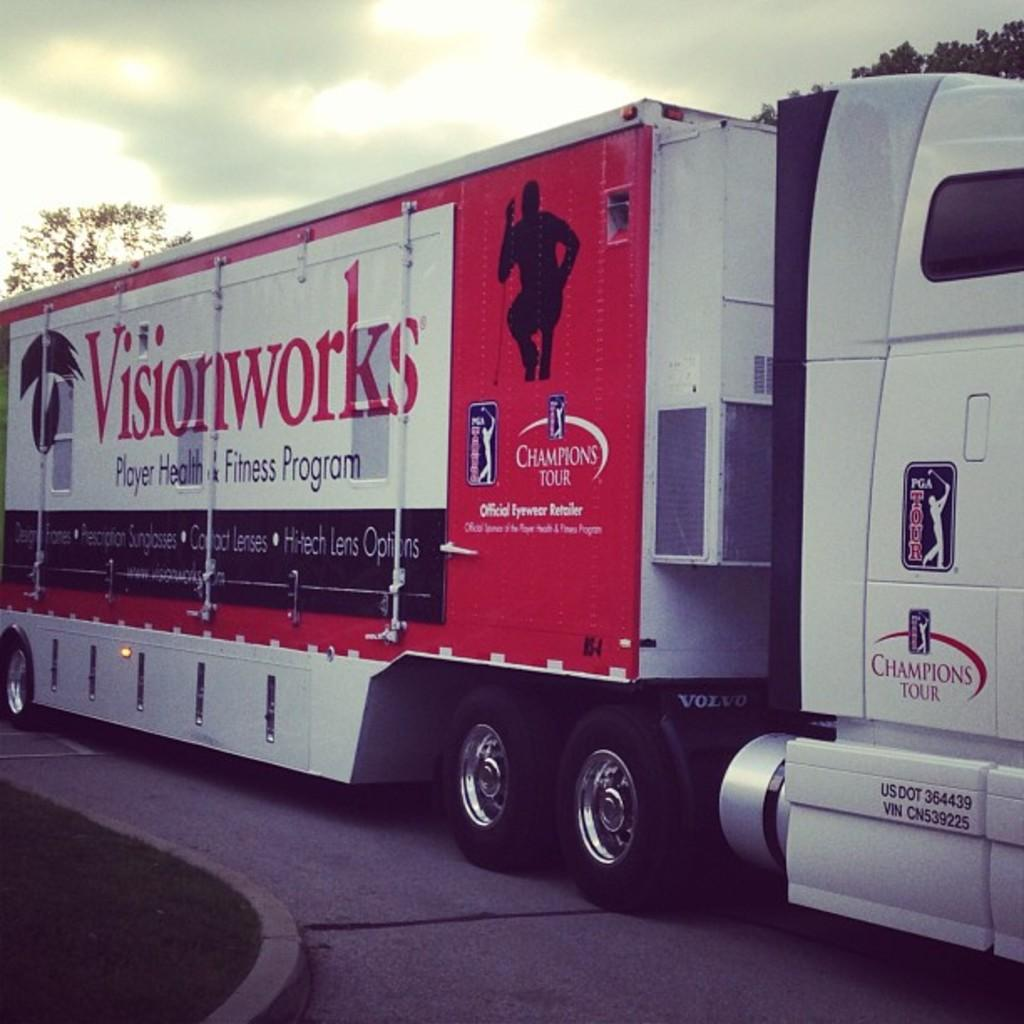What is the main subject of the image? There is a vehicle in the image. What colors can be seen on the vehicle? The vehicle has a white and red color scheme. What can be seen in the background of the image? There are trees and the sky visible in the background of the image. What is the color of the trees in the image? The trees are green. What is the color of the sky in the image? The sky is white. What type of soap can be seen hanging from the trees in the image? There is no soap present in the image; it features a vehicle with a white and red color scheme, green trees, and a white sky in the background. What sound do the bells make in the image? There are no bells present in the image. 